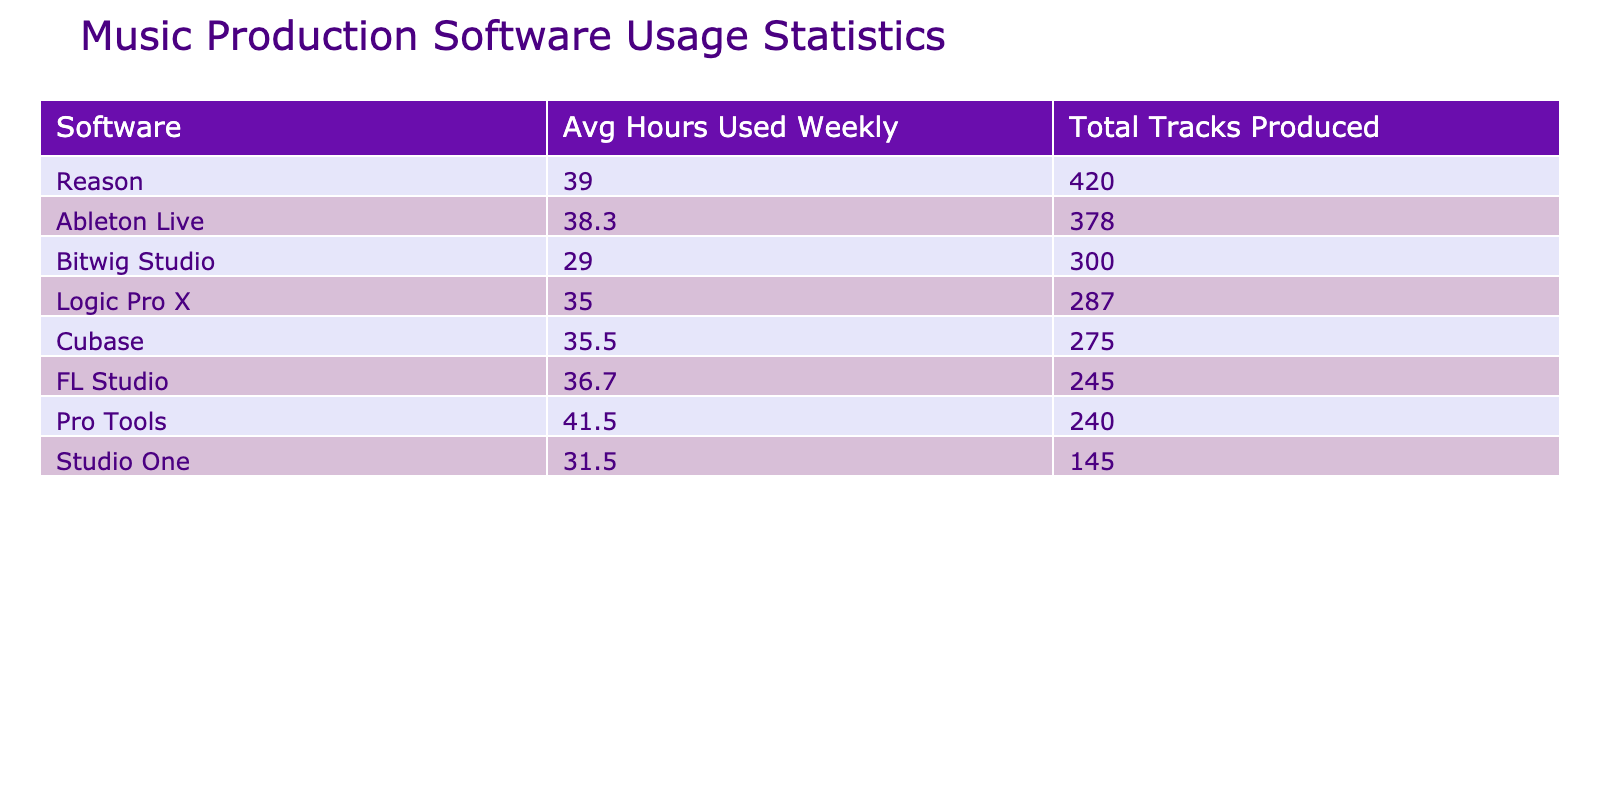What is the average number of hours used weekly for FL Studio? To find the average for FL Studio, we look at the "Avg Hours Used Weekly" column next to FL Studio in the table. The value listed there is 36.5.
Answer: 36.5 Which software had the highest number of tracks produced? By examining the "Total Tracks Produced" column, we identify which software has the highest sum. Reason had the highest with 220 tracks.
Answer: Reason Is it true that Ableton Live has an average hours used weekly greater than 35? Checking the "Avg Hours Used Weekly" for Ableton Live, the value is 38. This confirms that it is greater than 35.
Answer: Yes What is the total number of tracks produced by artists using Logic Pro X? We need to sum the values in the "Tracks Produced" column for Logic Pro X. The artists are Zedd with 120, Porter Robinson with 85, and Odesza with 82. Therefore, the total is 120 + 85 + 82 = 287.
Answer: 287 How many artists produced more than 100 tracks in total? Analyzing the "Tracks Produced" column, the artists with more than 100 tracks are Calvin Harris (150), Zedd (120), Deadmau5 (200), Daft Punk (180), Martin Garrix (100), The Chainsmokers (110), and Aphex Twin (220). That's a total of 6 artists.
Answer: 6 Which software has the lowest average hours used weekly, and what is that average? Looking at the "Avg Hours Used Weekly" for each software, Bitwig Studio has the lowest with an average of 28 hours.
Answer: Bitwig Studio, 28 What is the average number of years of experience for artists using Pro Tools? The artists using Pro Tools are Skrillex (14), The Chainsmokers (10). We calculate the average by summing these years (14 + 10) = 24 and dividing by 2, resulting in an average of 12 years.
Answer: 12 How many software options have an average hours used weekly of less than 35? Check each software's average in the "Avg Hours Used Weekly" column. Software with averages below 35 are Bitwig Studio (28), Studio One (31), and Logic Pro X (33), totaling 3 options.
Answer: 3 Is Cubase among the top three software in terms of total tracks produced? Comparing the "Total Tracks Produced" for each software, Cubase produced 180 tracks, which is within the top three highest totals (Reason, Ableton Live, Daft Punk). Therefore, it is included.
Answer: Yes 